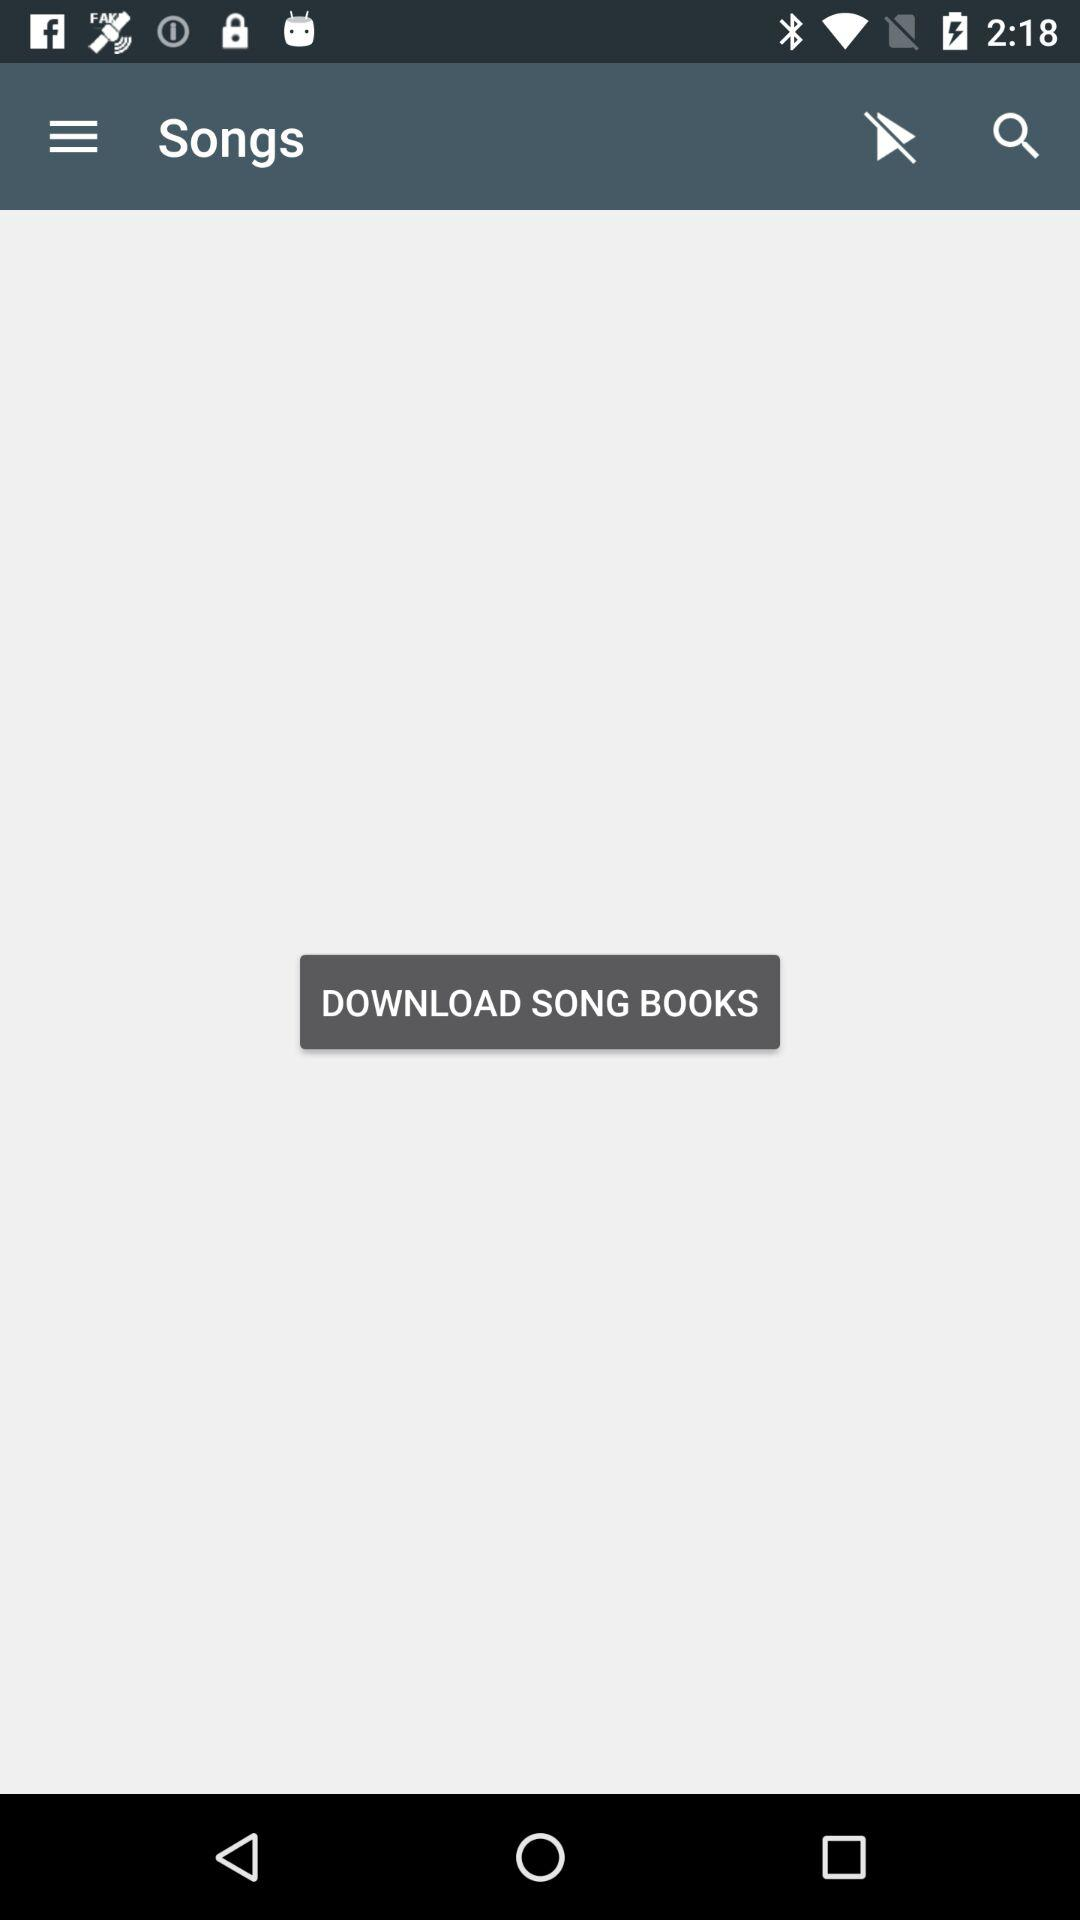What is the application name? The application name is "Songs". 